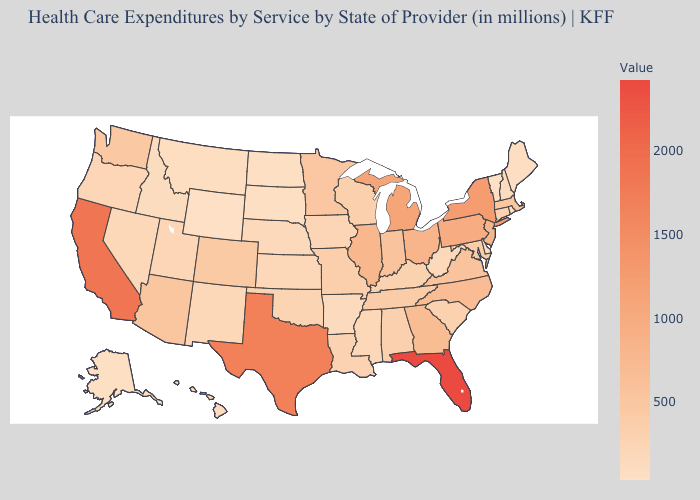Which states have the lowest value in the Northeast?
Quick response, please. Vermont. Does Florida have the highest value in the USA?
Give a very brief answer. Yes. Which states have the highest value in the USA?
Concise answer only. Florida. Which states hav the highest value in the MidWest?
Quick response, please. Michigan. Does Florida have the highest value in the USA?
Give a very brief answer. Yes. Among the states that border North Dakota , does South Dakota have the lowest value?
Answer briefly. Yes. 